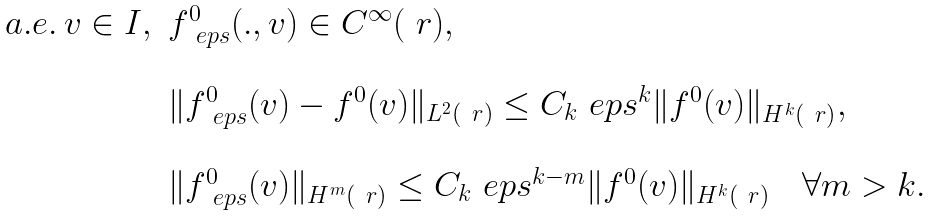Convert formula to latex. <formula><loc_0><loc_0><loc_500><loc_500>\begin{array} { l l l } a . e . \, v \in I , & f _ { \ e p s } ^ { 0 } ( . , v ) \in C ^ { \infty } ( \ r ) , \\ \\ & \| f _ { \ e p s } ^ { 0 } ( v ) - f ^ { 0 } ( v ) \| _ { L ^ { 2 } ( \ r ) } \leq C _ { k } \ e p s ^ { k } \| f ^ { 0 } ( v ) \| _ { H ^ { k } ( \ r ) } , \\ \\ & \| f _ { \ e p s } ^ { 0 } ( v ) \| _ { H ^ { m } ( \ r ) } \leq C _ { k } \ e p s ^ { k - m } \| f ^ { 0 } ( v ) \| _ { H ^ { k } ( \ r ) } \quad \forall m > k . \end{array}</formula> 